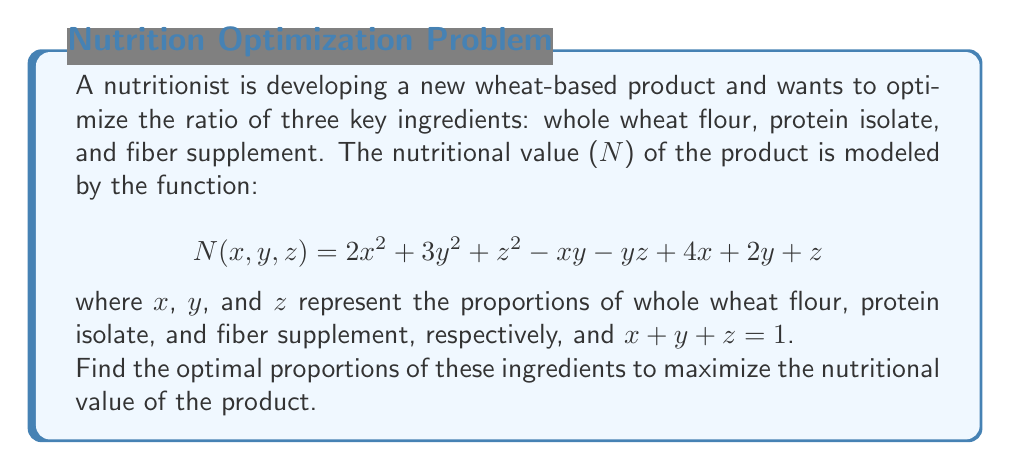Show me your answer to this math problem. To find the optimal proportions, we need to maximize the function N(x, y, z) subject to the constraint x + y + z = 1. We can use the method of Lagrange multipliers:

1) Define the Lagrangian function:
   $$L(x, y, z, λ) = 2x^2 + 3y^2 + z^2 - xy - yz + 4x + 2y + z + λ(1 - x - y - z)$$

2) Take partial derivatives and set them equal to zero:
   $$\frac{\partial L}{\partial x} = 4x - y + 4 - λ = 0$$
   $$\frac{\partial L}{\partial y} = 6y - x - z + 2 - λ = 0$$
   $$\frac{\partial L}{\partial z} = 2z - y + 1 - λ = 0$$
   $$\frac{\partial L}{\partial λ} = 1 - x - y - z = 0$$

3) From the first equation:
   $$λ = 4x - y + 4$$

4) Substitute this into the second and third equations:
   $$6y - x - z + 2 - (4x - y + 4) = 0$$
   $$2z - y + 1 - (4x - y + 4) = 0$$

5) Simplify:
   $$7y - 5x - z - 2 = 0$$
   $$2z + y - 4x - 3 = 0$$

6) From the constraint equation:
   $$z = 1 - x - y$$

7) Substitute this into the equations from step 5:
   $$7y - 5x - (1 - x - y) - 2 = 0$$
   $$2(1 - x - y) + y - 4x - 3 = 0$$

8) Simplify:
   $$8y - 4x = 3$$
   $$-2x - y = 1$$

9) Solve this system of equations:
   Multiply the second equation by 4: $$-8x - 4y = 4$$
   Add this to the first equation: $$4y - 12x = 7$$
   $$y = 3x + \frac{7}{4}$$

   Substitute this into $$-2x - y = 1$$:
   $$-2x - (3x + \frac{7}{4}) = 1$$
   $$-5x - \frac{7}{4} = 1$$
   $$-5x = \frac{11}{4}$$
   $$x = -\frac{11}{20}$$

   $$y = 3(-\frac{11}{20}) + \frac{7}{4} = \frac{9}{20}$$
   $$z = 1 - (-\frac{11}{20}) - \frac{9}{20} = \frac{11}{10}$$

10) However, since x, y, and z represent proportions, they must be non-negative and sum to 1. The solution we found doesn't satisfy these conditions.

11) Therefore, the maximum must occur on the boundary of the constraint. Let's check the vertices of the triangle formed by x + y + z = 1 in the first quadrant:

    At (1, 0, 0): N = 6
    At (0, 1, 0): N = 5
    At (0, 0, 1): N = 1

The maximum occurs at (1, 0, 0).
Answer: (1, 0, 0) 